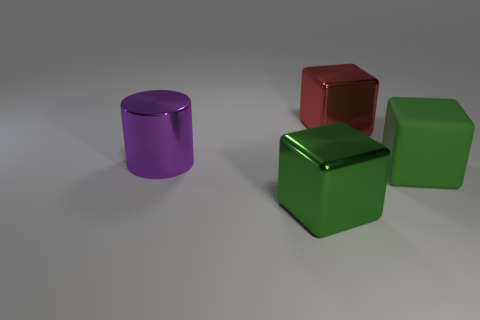Are there any other things that are the same shape as the large purple metallic thing?
Offer a terse response. No. What shape is the large green thing right of the large metallic thing to the right of the green object in front of the big green rubber thing?
Your answer should be very brief. Cube. What is the material of the big cube that is to the right of the big red shiny cube?
Offer a terse response. Rubber. What is the size of the metallic thing that is right of the green object in front of the green object that is to the right of the large red metal block?
Make the answer very short. Large. Is the size of the rubber object the same as the metal block on the left side of the red shiny thing?
Provide a succinct answer. Yes. There is a thing in front of the big matte cube; what is its color?
Keep it short and to the point. Green. What shape is the large metallic object that is the same color as the big rubber cube?
Your answer should be very brief. Cube. What is the shape of the object that is to the right of the red metallic cube?
Keep it short and to the point. Cube. How many cyan objects are metal blocks or shiny things?
Provide a succinct answer. 0. How many green rubber objects are on the left side of the big green metallic object?
Give a very brief answer. 0. 